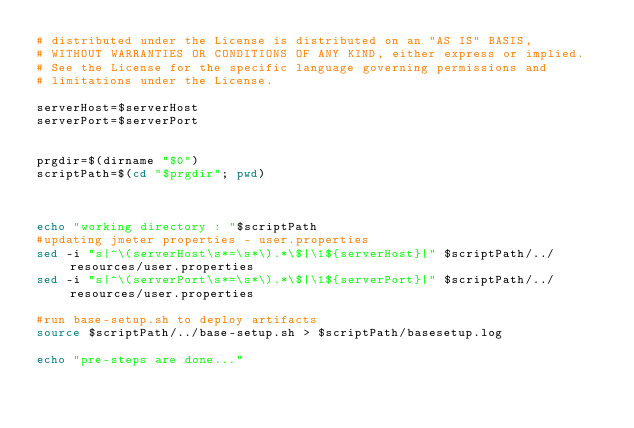Convert code to text. <code><loc_0><loc_0><loc_500><loc_500><_Bash_># distributed under the License is distributed on an "AS IS" BASIS,
# WITHOUT WARRANTIES OR CONDITIONS OF ANY KIND, either express or implied.
# See the License for the specific language governing permissions and
# limitations under the License.

serverHost=$serverHost
serverPort=$serverPort


prgdir=$(dirname "$0")
scriptPath=$(cd "$prgdir"; pwd)



echo "working directory : "$scriptPath
#updating jmeter properties - user.properties
sed -i "s|^\(serverHost\s*=\s*\).*\$|\1${serverHost}|" $scriptPath/../resources/user.properties
sed -i "s|^\(serverPort\s*=\s*\).*\$|\1${serverPort}|" $scriptPath/../resources/user.properties

#run base-setup.sh to deploy artifacts
source $scriptPath/../base-setup.sh > $scriptPath/basesetup.log

echo "pre-steps are done..."
</code> 